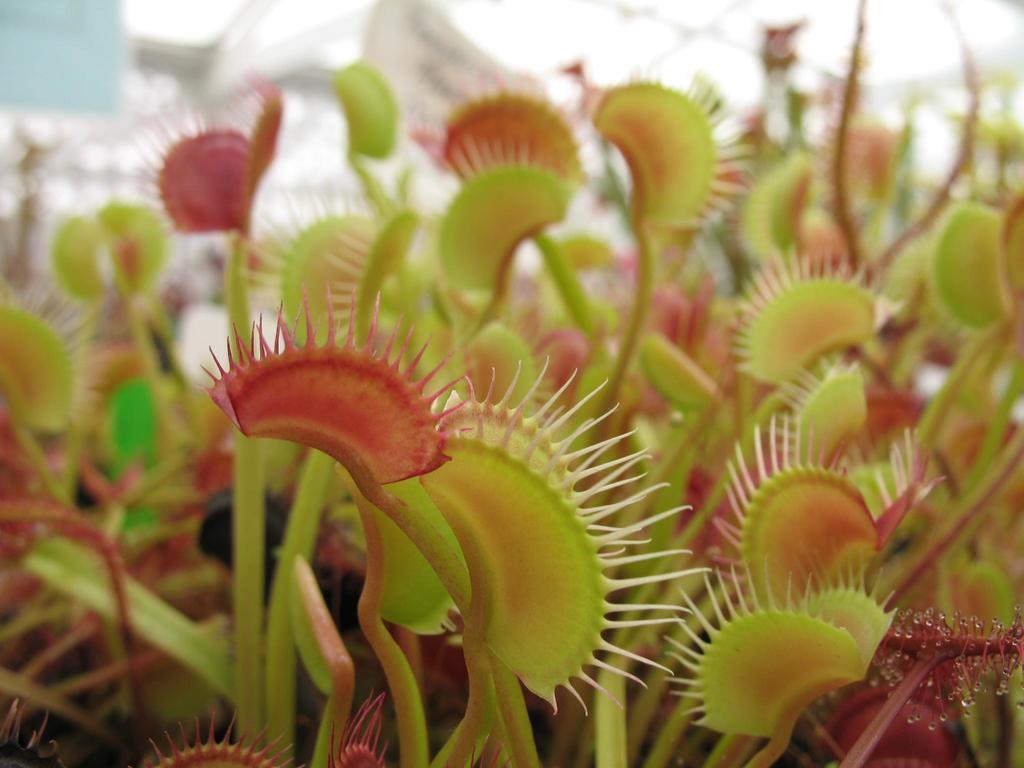Please provide a concise description of this image. In this image I can see carnivorous plants and there is a blur background. 